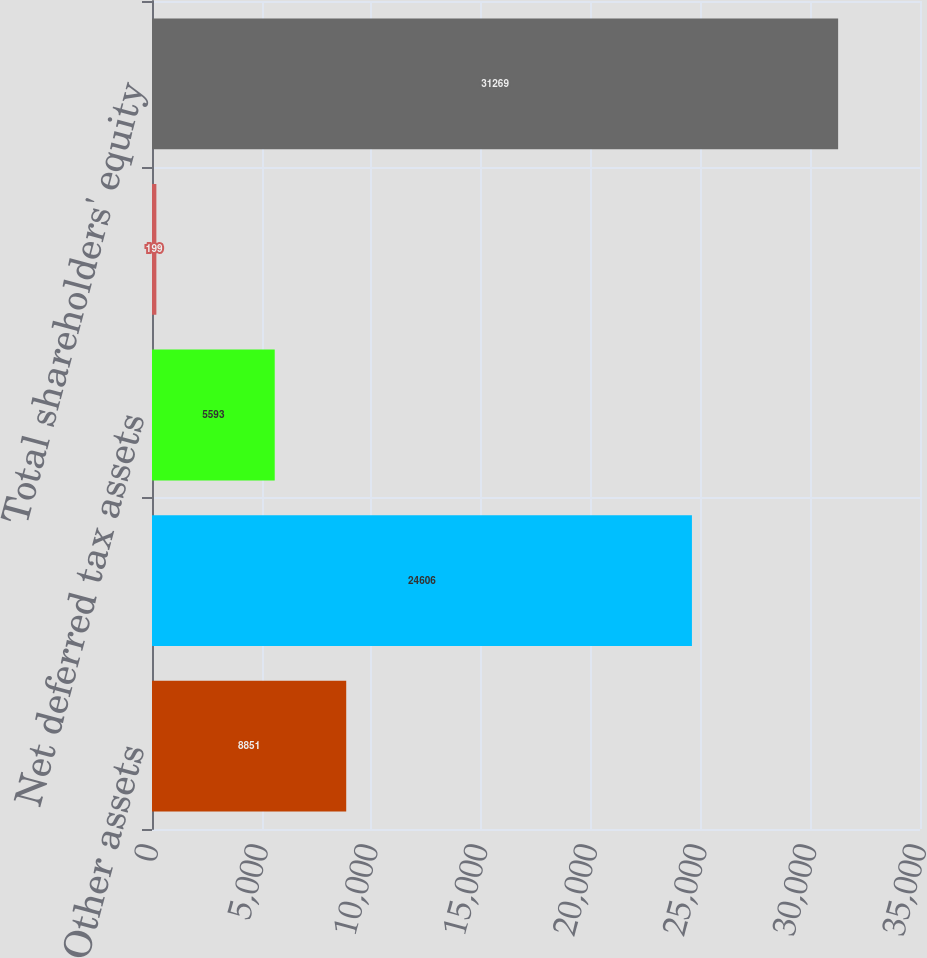Convert chart. <chart><loc_0><loc_0><loc_500><loc_500><bar_chart><fcel>Other assets<fcel>Other liabilities and accrued<fcel>Net deferred tax assets<fcel>Accumulated other<fcel>Total shareholders' equity<nl><fcel>8851<fcel>24606<fcel>5593<fcel>199<fcel>31269<nl></chart> 